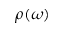<formula> <loc_0><loc_0><loc_500><loc_500>\rho ( \omega )</formula> 